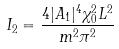<formula> <loc_0><loc_0><loc_500><loc_500>I _ { 2 } = \frac { 4 | A _ { 1 } | ^ { 4 } \chi _ { 0 } ^ { 2 } L ^ { 2 } } { m ^ { 2 } \pi ^ { 2 } }</formula> 